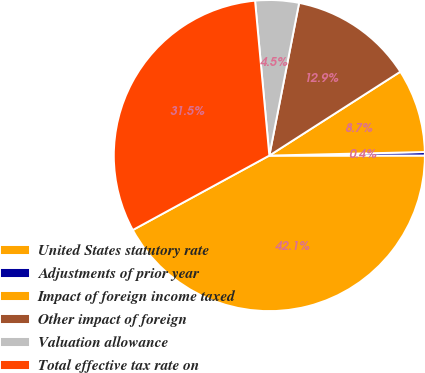Convert chart. <chart><loc_0><loc_0><loc_500><loc_500><pie_chart><fcel>United States statutory rate<fcel>Adjustments of prior year<fcel>Impact of foreign income taxed<fcel>Other impact of foreign<fcel>Valuation allowance<fcel>Total effective tax rate on<nl><fcel>42.06%<fcel>0.36%<fcel>8.7%<fcel>12.87%<fcel>4.53%<fcel>31.48%<nl></chart> 